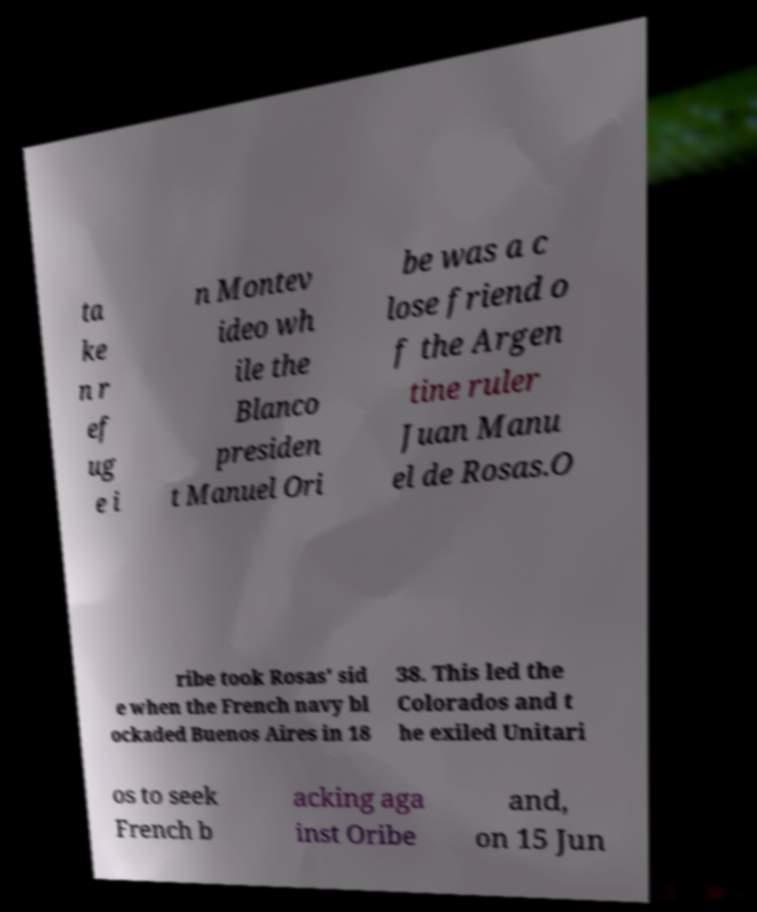Can you read and provide the text displayed in the image?This photo seems to have some interesting text. Can you extract and type it out for me? ta ke n r ef ug e i n Montev ideo wh ile the Blanco presiden t Manuel Ori be was a c lose friend o f the Argen tine ruler Juan Manu el de Rosas.O ribe took Rosas' sid e when the French navy bl ockaded Buenos Aires in 18 38. This led the Colorados and t he exiled Unitari os to seek French b acking aga inst Oribe and, on 15 Jun 